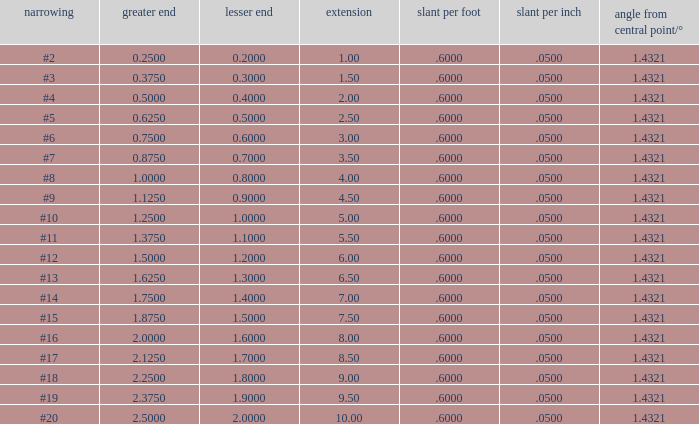Which Taper/in that has a Small end larger than 0.7000000000000001, and a Taper of #19, and a Large end larger than 2.375? None. 